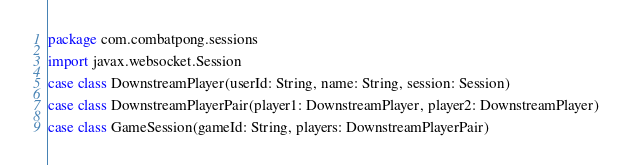<code> <loc_0><loc_0><loc_500><loc_500><_Scala_>package com.combatpong.sessions

import javax.websocket.Session

case class DownstreamPlayer(userId: String, name: String, session: Session)

case class DownstreamPlayerPair(player1: DownstreamPlayer, player2: DownstreamPlayer)

case class GameSession(gameId: String, players: DownstreamPlayerPair)
</code> 